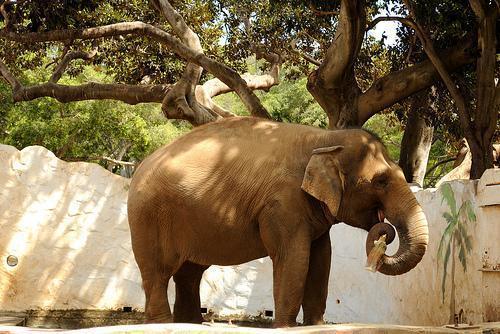How many elephants?
Give a very brief answer. 1. 